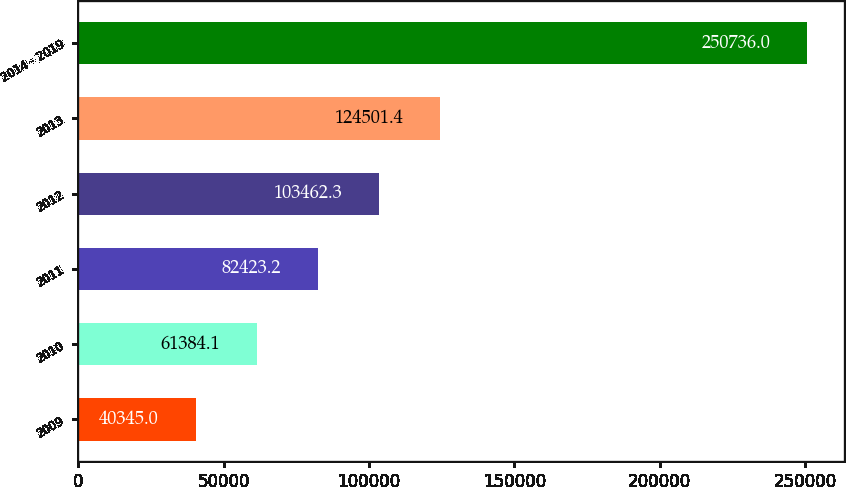<chart> <loc_0><loc_0><loc_500><loc_500><bar_chart><fcel>2009<fcel>2010<fcel>2011<fcel>2012<fcel>2013<fcel>2014 - 2019<nl><fcel>40345<fcel>61384.1<fcel>82423.2<fcel>103462<fcel>124501<fcel>250736<nl></chart> 